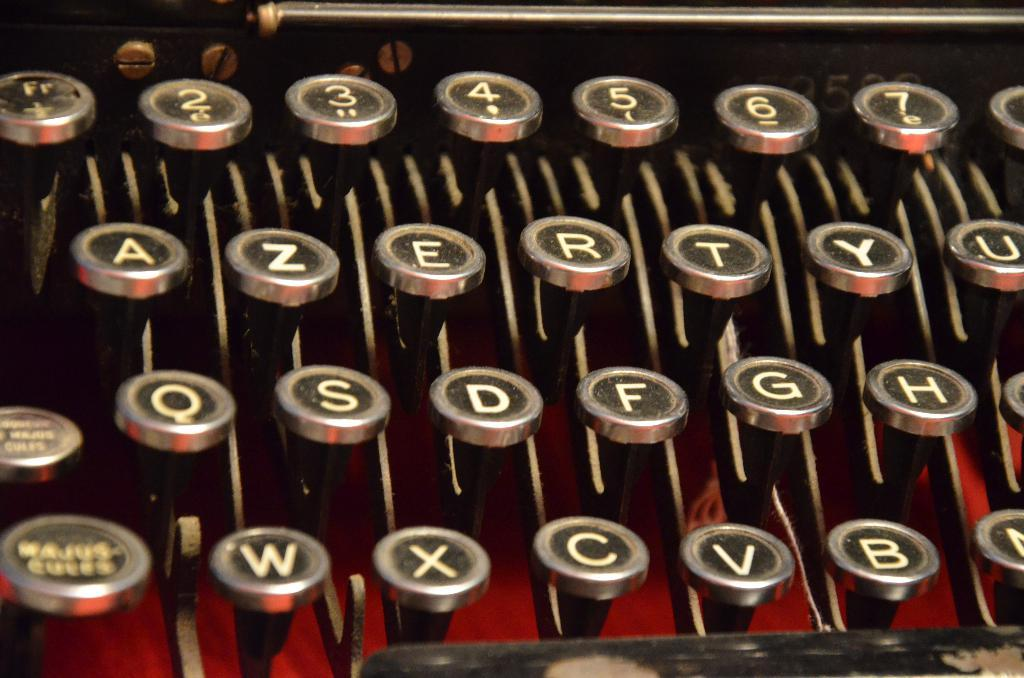<image>
Render a clear and concise summary of the photo. manual typewriter close up showing keys 1,2,3,4,5,6,7, A,Z,E,R,T,Y,U, Q,S,D,F,G,H,W,X,C,V, and B 